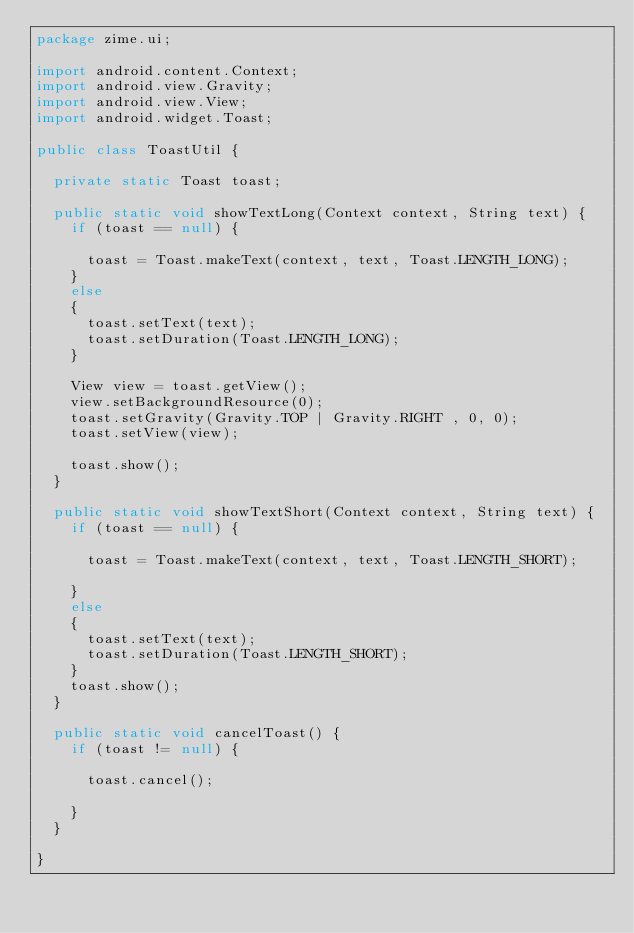<code> <loc_0><loc_0><loc_500><loc_500><_Java_>package zime.ui;

import android.content.Context;
import android.view.Gravity;
import android.view.View;
import android.widget.Toast;

public class ToastUtil {

	private static Toast toast;

	public static void showTextLong(Context context, String text) {
		if (toast == null) {

			toast = Toast.makeText(context, text, Toast.LENGTH_LONG);
		}
		else
		{
			toast.setText(text);
			toast.setDuration(Toast.LENGTH_LONG);
		}

		View view = toast.getView();
		view.setBackgroundResource(0);
		toast.setGravity(Gravity.TOP | Gravity.RIGHT , 0, 0);
		toast.setView(view);

		toast.show();
	}

	public static void showTextShort(Context context, String text) {
		if (toast == null) {

			toast = Toast.makeText(context, text, Toast.LENGTH_SHORT);

		}
		else
		{
			toast.setText(text);
			toast.setDuration(Toast.LENGTH_SHORT);
		}
		toast.show();
	}

	public static void cancelToast() {
		if (toast != null) {

			toast.cancel();

		}
	}

}
</code> 